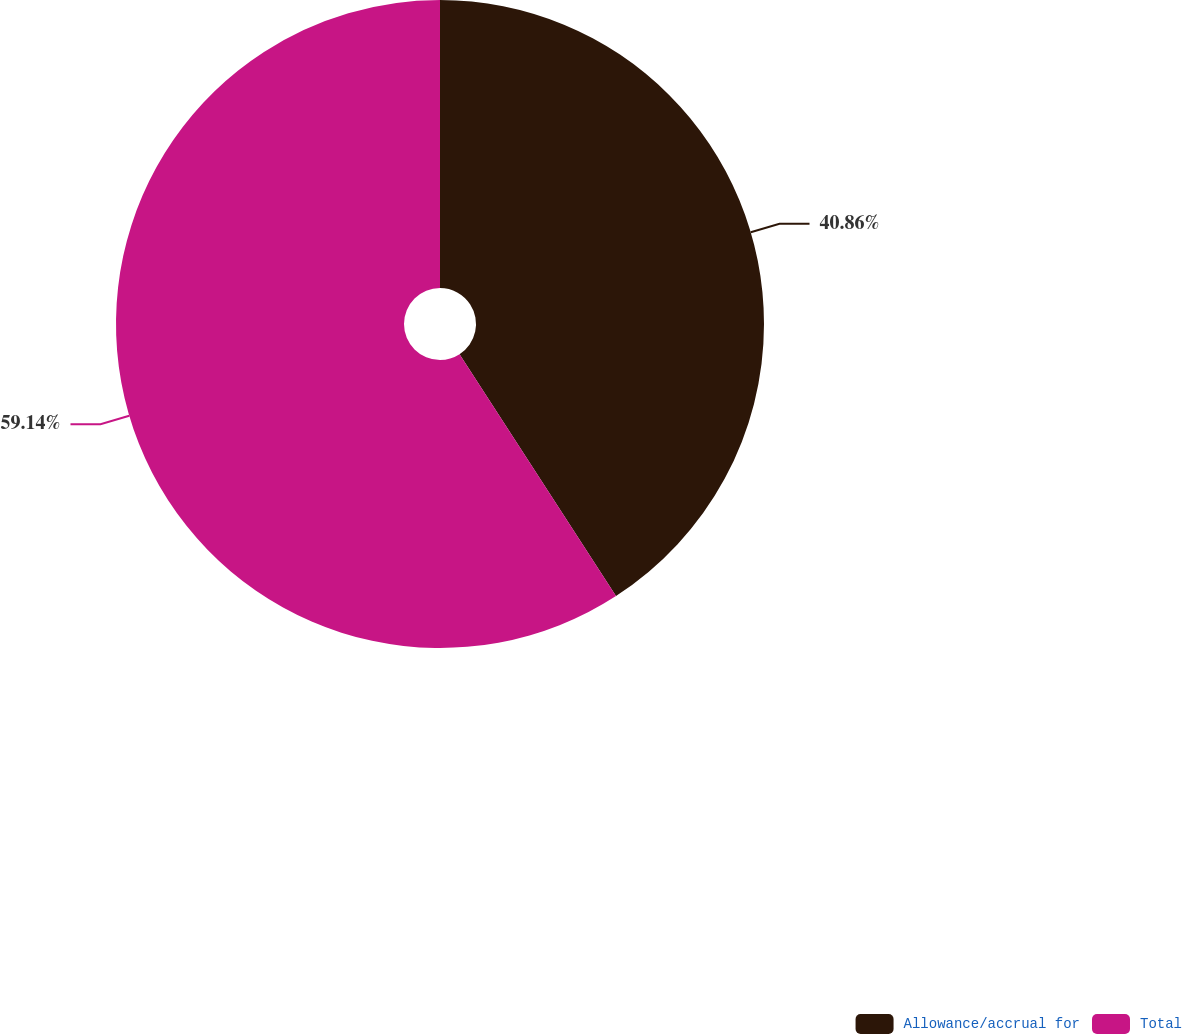Convert chart. <chart><loc_0><loc_0><loc_500><loc_500><pie_chart><fcel>Allowance/accrual for<fcel>Total<nl><fcel>40.86%<fcel>59.14%<nl></chart> 